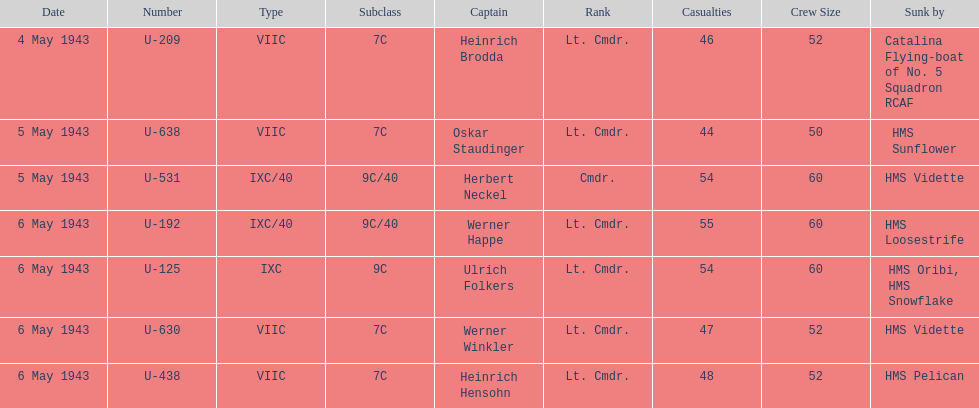What was the only captain sunk by hms pelican? Heinrich Hensohn. 